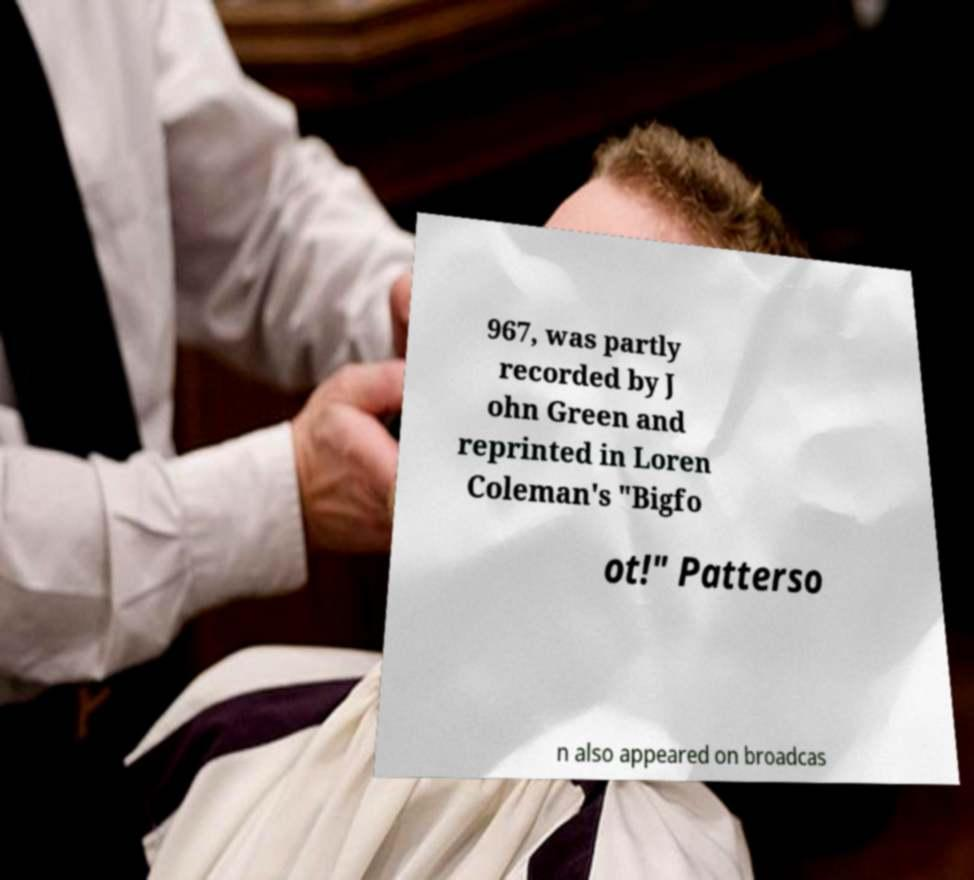I need the written content from this picture converted into text. Can you do that? 967, was partly recorded by J ohn Green and reprinted in Loren Coleman's "Bigfo ot!" Patterso n also appeared on broadcas 